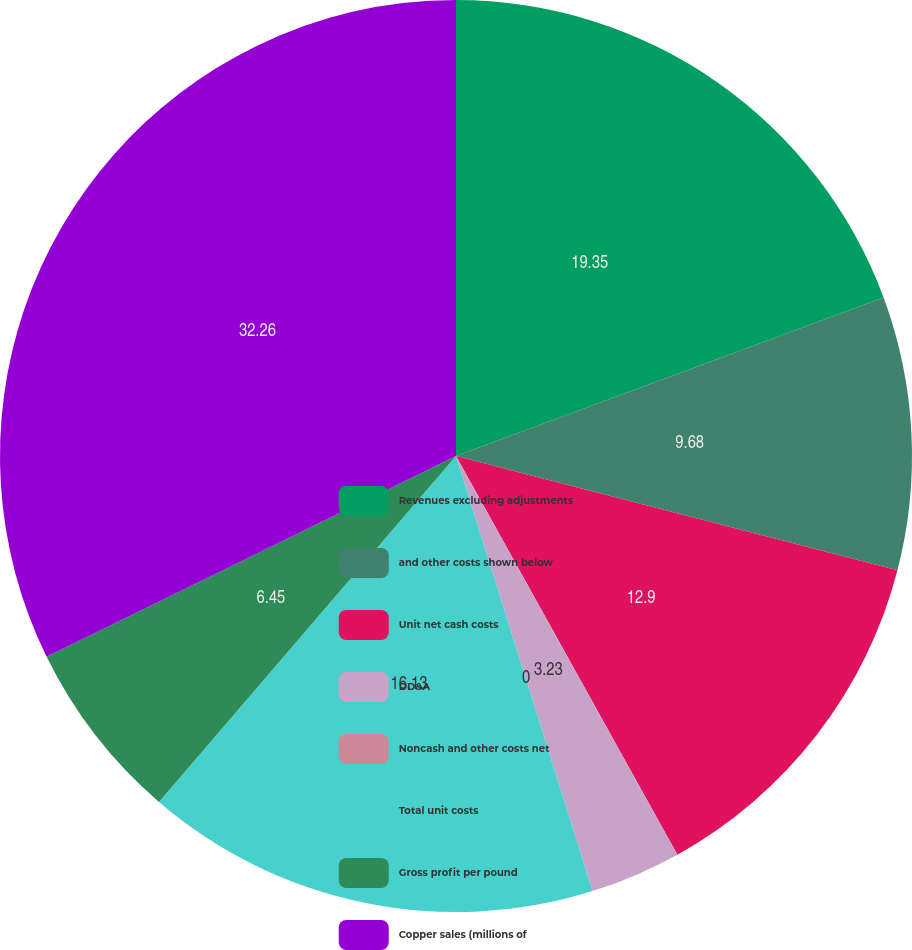Convert chart. <chart><loc_0><loc_0><loc_500><loc_500><pie_chart><fcel>Revenues excluding adjustments<fcel>and other costs shown below<fcel>Unit net cash costs<fcel>DD&A<fcel>Noncash and other costs net<fcel>Total unit costs<fcel>Gross profit per pound<fcel>Copper sales (millions of<nl><fcel>19.35%<fcel>9.68%<fcel>12.9%<fcel>3.23%<fcel>0.0%<fcel>16.13%<fcel>6.45%<fcel>32.26%<nl></chart> 